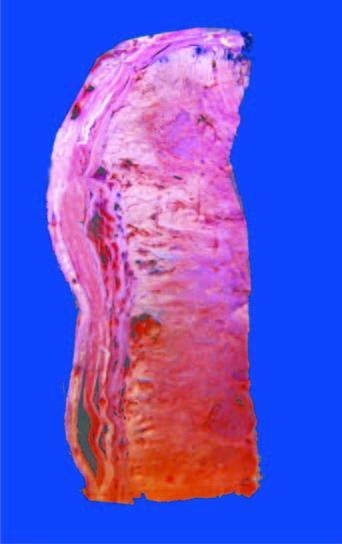s section from margin of amoebic ulcer largely extending into soft tissues including the skeletal muscle?
Answer the question using a single word or phrase. No 